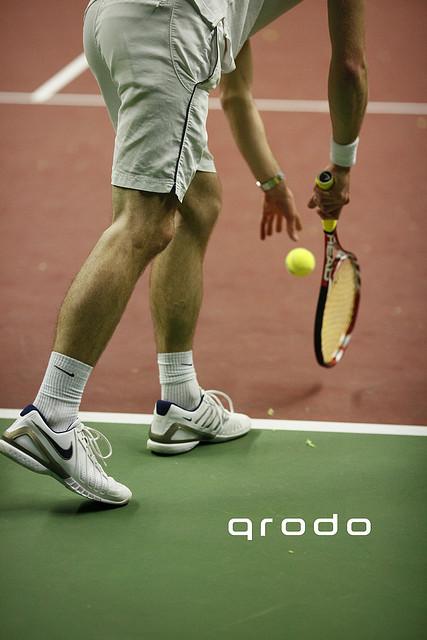Where is the ball?
Write a very short answer. Air. What is the man about to do?
Keep it brief. Serve ball. What brand shoes is the player wearing?
Give a very brief answer. Nike. 